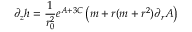Convert formula to latex. <formula><loc_0><loc_0><loc_500><loc_500>\partial _ { z } h = \frac { 1 } { r _ { 0 } ^ { 2 } } e ^ { A + 3 C } \left ( m + r ( m + r ^ { 2 } ) \partial _ { r } A \right )</formula> 